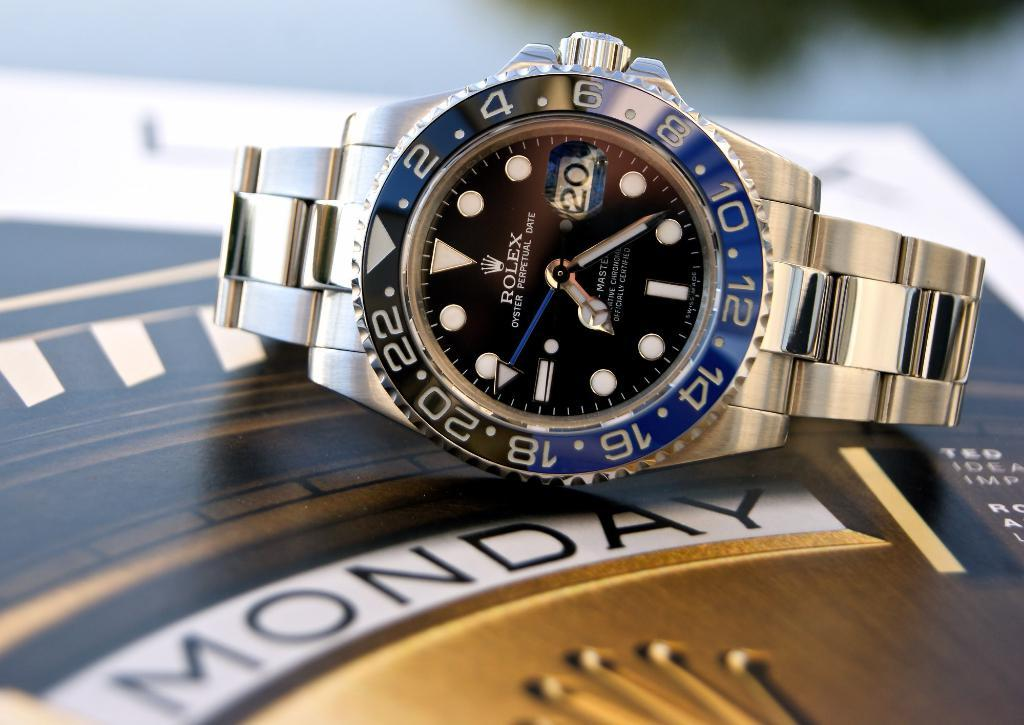<image>
Render a clear and concise summary of the photo. a rolex watch that is above a label that says 'monday' 